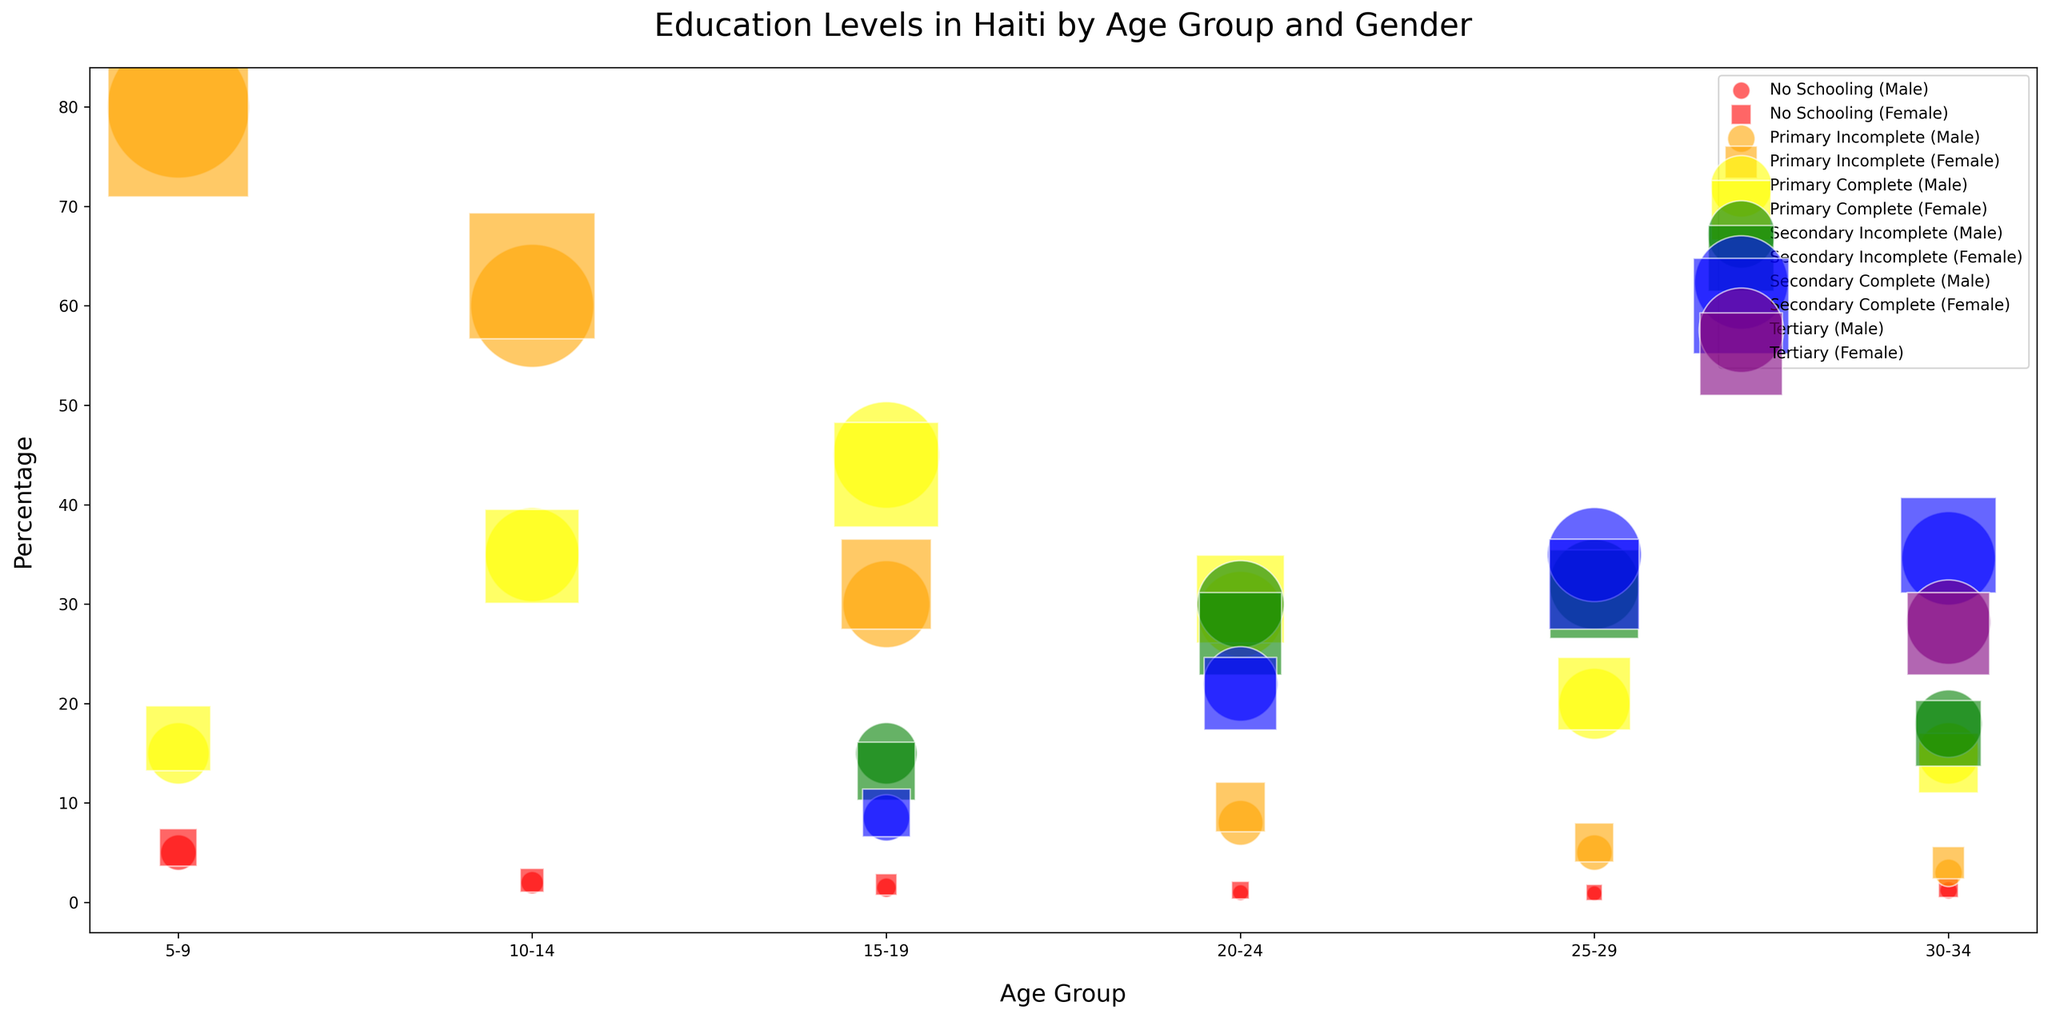What age group has the highest percentage of "No Schooling" for females? The highest percentage of "No Schooling" for females can be found by looking at all the age groups and noting the "No Schooling" percentages. The age group with the highest percentage for females is 5-9 (5.5%).
Answer: 5-9 Which gender has a larger percentage of "Primary Complete" in the 20-24 age group? For the age group 20-24, compare the percentages of "Primary Complete" for males and females. Males have 29%, while females have 30.5%. Thus, females have a larger percentage.
Answer: Female What is the total number of individuals aged 15-19 who have "Secondary Complete" education? Add up the counts of males and females aged 15-19 with "Secondary Complete". Males have 8,500, and females have 9,000. So, 8,500 + 9,000 = 17,500.
Answer: 17,500 How does the percentage of "Tertiary" education in the 30-34 age group compare between genders? Compare the "Tertiary" education percentages for males and females in the 30-34 age group. Males have 28.2%, and females have 27%. Thus, males have a slightly higher percentage.
Answer: Males have a slightly higher percentage Which education level has the largest bubble size in the 10-14 age group? The largest bubble size corresponds to the highest count. In the 10-14 age group, "Primary Incomplete" has the largest count for both genders (60,000 males, 63,000 females), which means it has the largest bubble size.
Answer: Primary Incomplete What is the difference in percentage of "Secondary Incomplete" education between males and females in the 25-29 age group? Subtract the female percentage from the male percentage for "Secondary Incomplete" in the 25-29 age group. Males have 32%, females have 31%, so the difference is 32% - 31% = 1%.
Answer: 1% What is the combined percentage of "Primary Complete" for males and females in the 15-19 age group? Add the percentages of "Primary Complete" for both males and females in the 15-19 age group. Males have 45%, females have 43%, so the combined percentage is 45% + 43% = 88%.
Answer: 88% Which age group shows the highest percentage of "Secondary Complete" education for males? Look for the highest percentage of "Secondary Complete" among all age groups for males. The highest percentage is 34.6% in the 30-34 age group.
Answer: 30-34 How do "No Schooling" percentages compare between the 5-9 and 20-24 age groups for females? Look at the "No Schooling" percentages for females in the 5-9 (5.5%) and 20-24 (1.2%) age groups and compare them. The percentage is higher in the 5-9 age group.
Answer: Higher in 5-9 